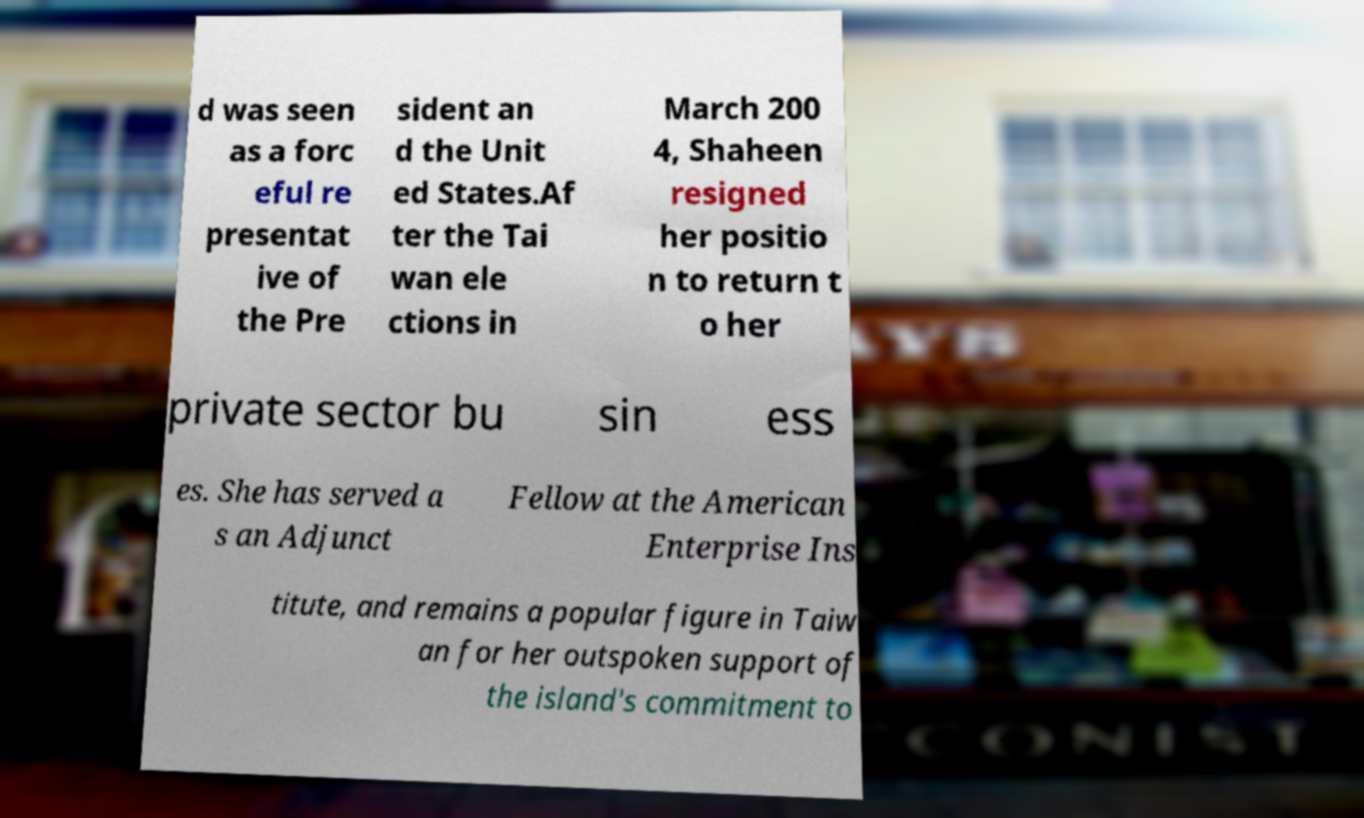Could you extract and type out the text from this image? d was seen as a forc eful re presentat ive of the Pre sident an d the Unit ed States.Af ter the Tai wan ele ctions in March 200 4, Shaheen resigned her positio n to return t o her private sector bu sin ess es. She has served a s an Adjunct Fellow at the American Enterprise Ins titute, and remains a popular figure in Taiw an for her outspoken support of the island's commitment to 